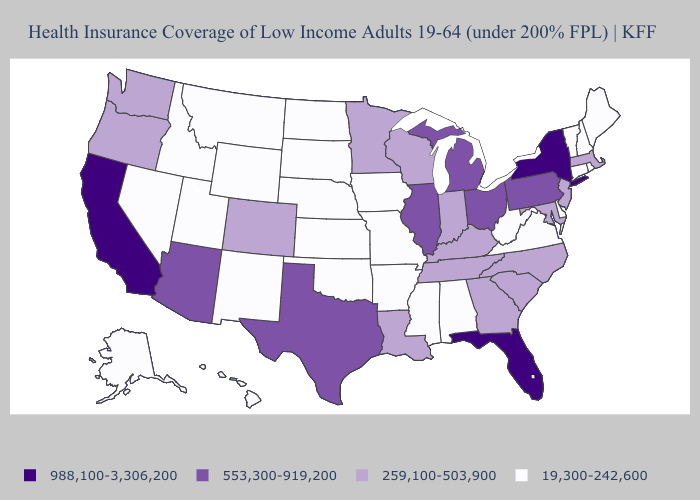Name the states that have a value in the range 553,300-919,200?
Be succinct. Arizona, Illinois, Michigan, Ohio, Pennsylvania, Texas. Does Indiana have the lowest value in the MidWest?
Give a very brief answer. No. What is the value of South Carolina?
Concise answer only. 259,100-503,900. Does Arkansas have the highest value in the USA?
Write a very short answer. No. What is the value of Maryland?
Be succinct. 259,100-503,900. Name the states that have a value in the range 988,100-3,306,200?
Keep it brief. California, Florida, New York. Does California have the highest value in the West?
Concise answer only. Yes. Does Missouri have the lowest value in the USA?
Keep it brief. Yes. What is the value of Texas?
Quick response, please. 553,300-919,200. What is the value of Wisconsin?
Give a very brief answer. 259,100-503,900. What is the value of Georgia?
Answer briefly. 259,100-503,900. Does the map have missing data?
Keep it brief. No. Which states hav the highest value in the West?
Write a very short answer. California. Does Hawaii have a higher value than Montana?
Give a very brief answer. No. Name the states that have a value in the range 988,100-3,306,200?
Write a very short answer. California, Florida, New York. 